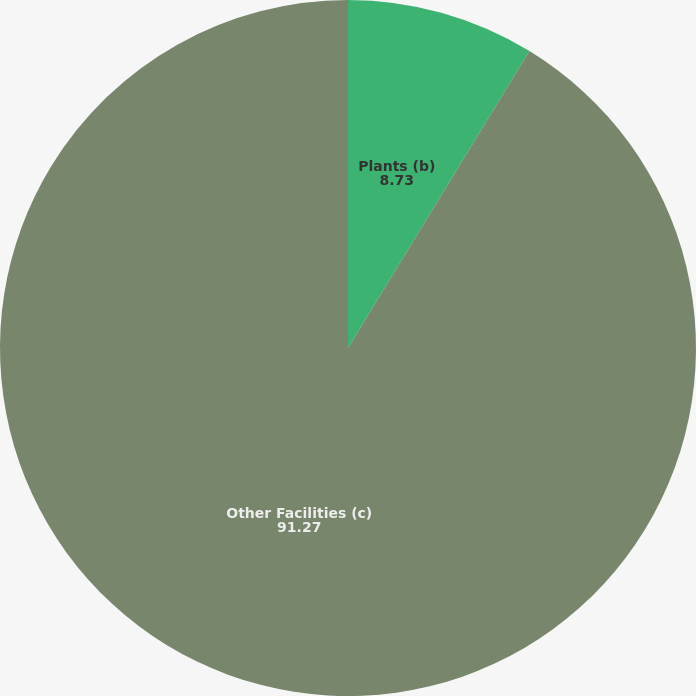<chart> <loc_0><loc_0><loc_500><loc_500><pie_chart><fcel>Plants (b)<fcel>Other Facilities (c)<nl><fcel>8.73%<fcel>91.27%<nl></chart> 